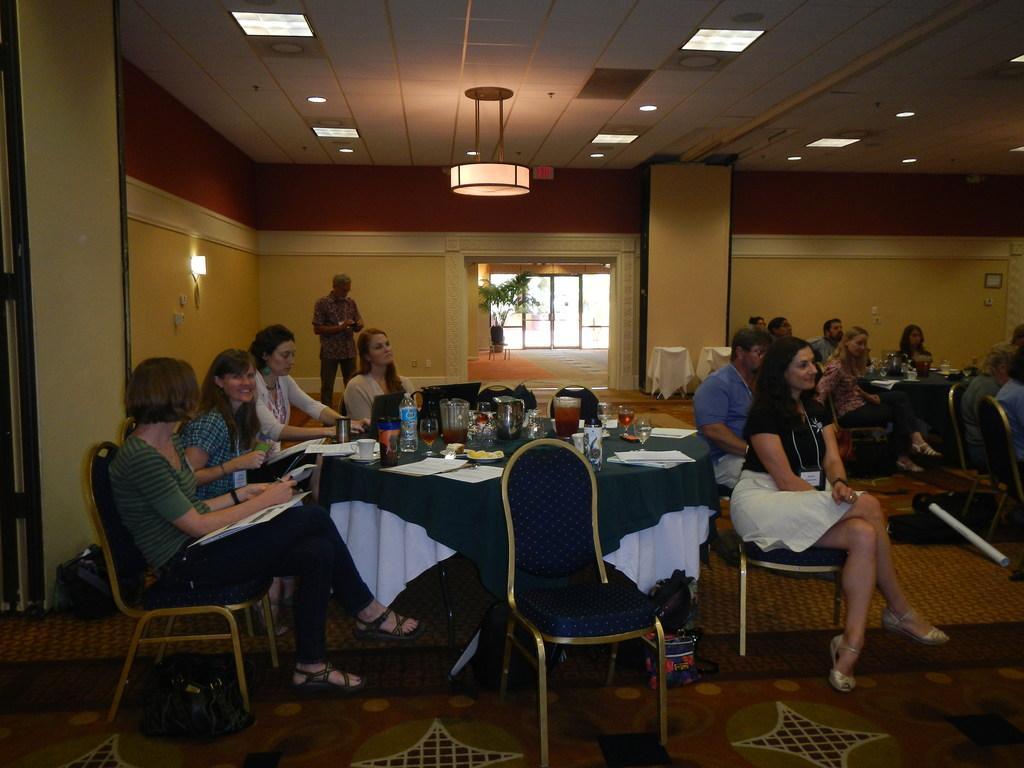Please provide a concise description of this image. This picture is an inside view of a room. In this picture we can see the tables and some people are sitting on the chairs. On the tables we can see the papers, glasses, bottles, plates of food and some other objects. In the background of the image we can see the wall, light, window, plant, pot, cloths and a man is standing. At the bottom of the image we can see the floor and bags. At the top of the image we can see the roof and lights. 